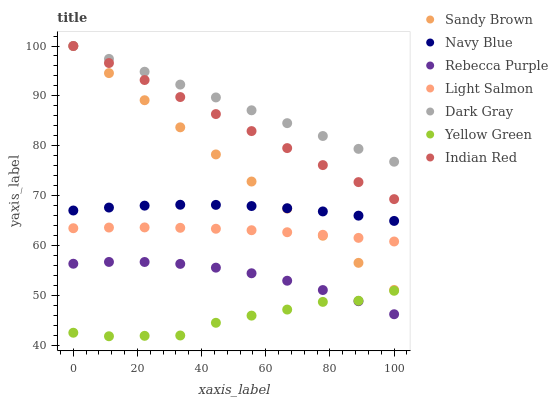Does Yellow Green have the minimum area under the curve?
Answer yes or no. Yes. Does Dark Gray have the maximum area under the curve?
Answer yes or no. Yes. Does Navy Blue have the minimum area under the curve?
Answer yes or no. No. Does Navy Blue have the maximum area under the curve?
Answer yes or no. No. Is Indian Red the smoothest?
Answer yes or no. Yes. Is Yellow Green the roughest?
Answer yes or no. Yes. Is Navy Blue the smoothest?
Answer yes or no. No. Is Navy Blue the roughest?
Answer yes or no. No. Does Yellow Green have the lowest value?
Answer yes or no. Yes. Does Navy Blue have the lowest value?
Answer yes or no. No. Does Sandy Brown have the highest value?
Answer yes or no. Yes. Does Navy Blue have the highest value?
Answer yes or no. No. Is Yellow Green less than Navy Blue?
Answer yes or no. Yes. Is Navy Blue greater than Light Salmon?
Answer yes or no. Yes. Does Indian Red intersect Dark Gray?
Answer yes or no. Yes. Is Indian Red less than Dark Gray?
Answer yes or no. No. Is Indian Red greater than Dark Gray?
Answer yes or no. No. Does Yellow Green intersect Navy Blue?
Answer yes or no. No. 